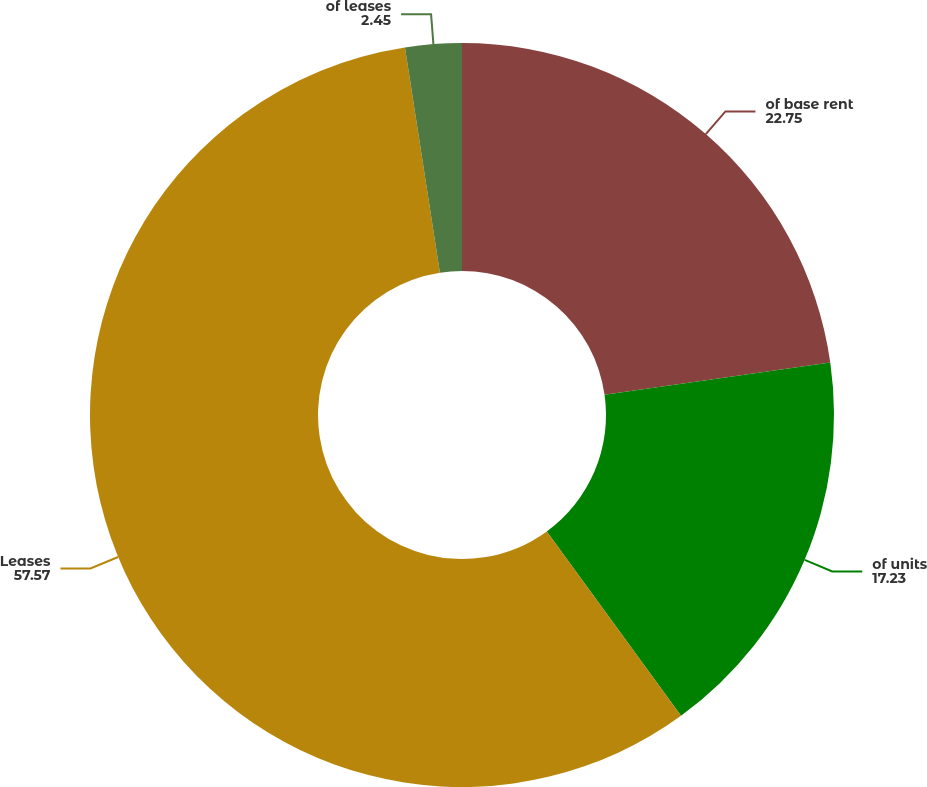<chart> <loc_0><loc_0><loc_500><loc_500><pie_chart><fcel>of base rent<fcel>of units<fcel>Leases<fcel>of leases<nl><fcel>22.75%<fcel>17.23%<fcel>57.57%<fcel>2.45%<nl></chart> 